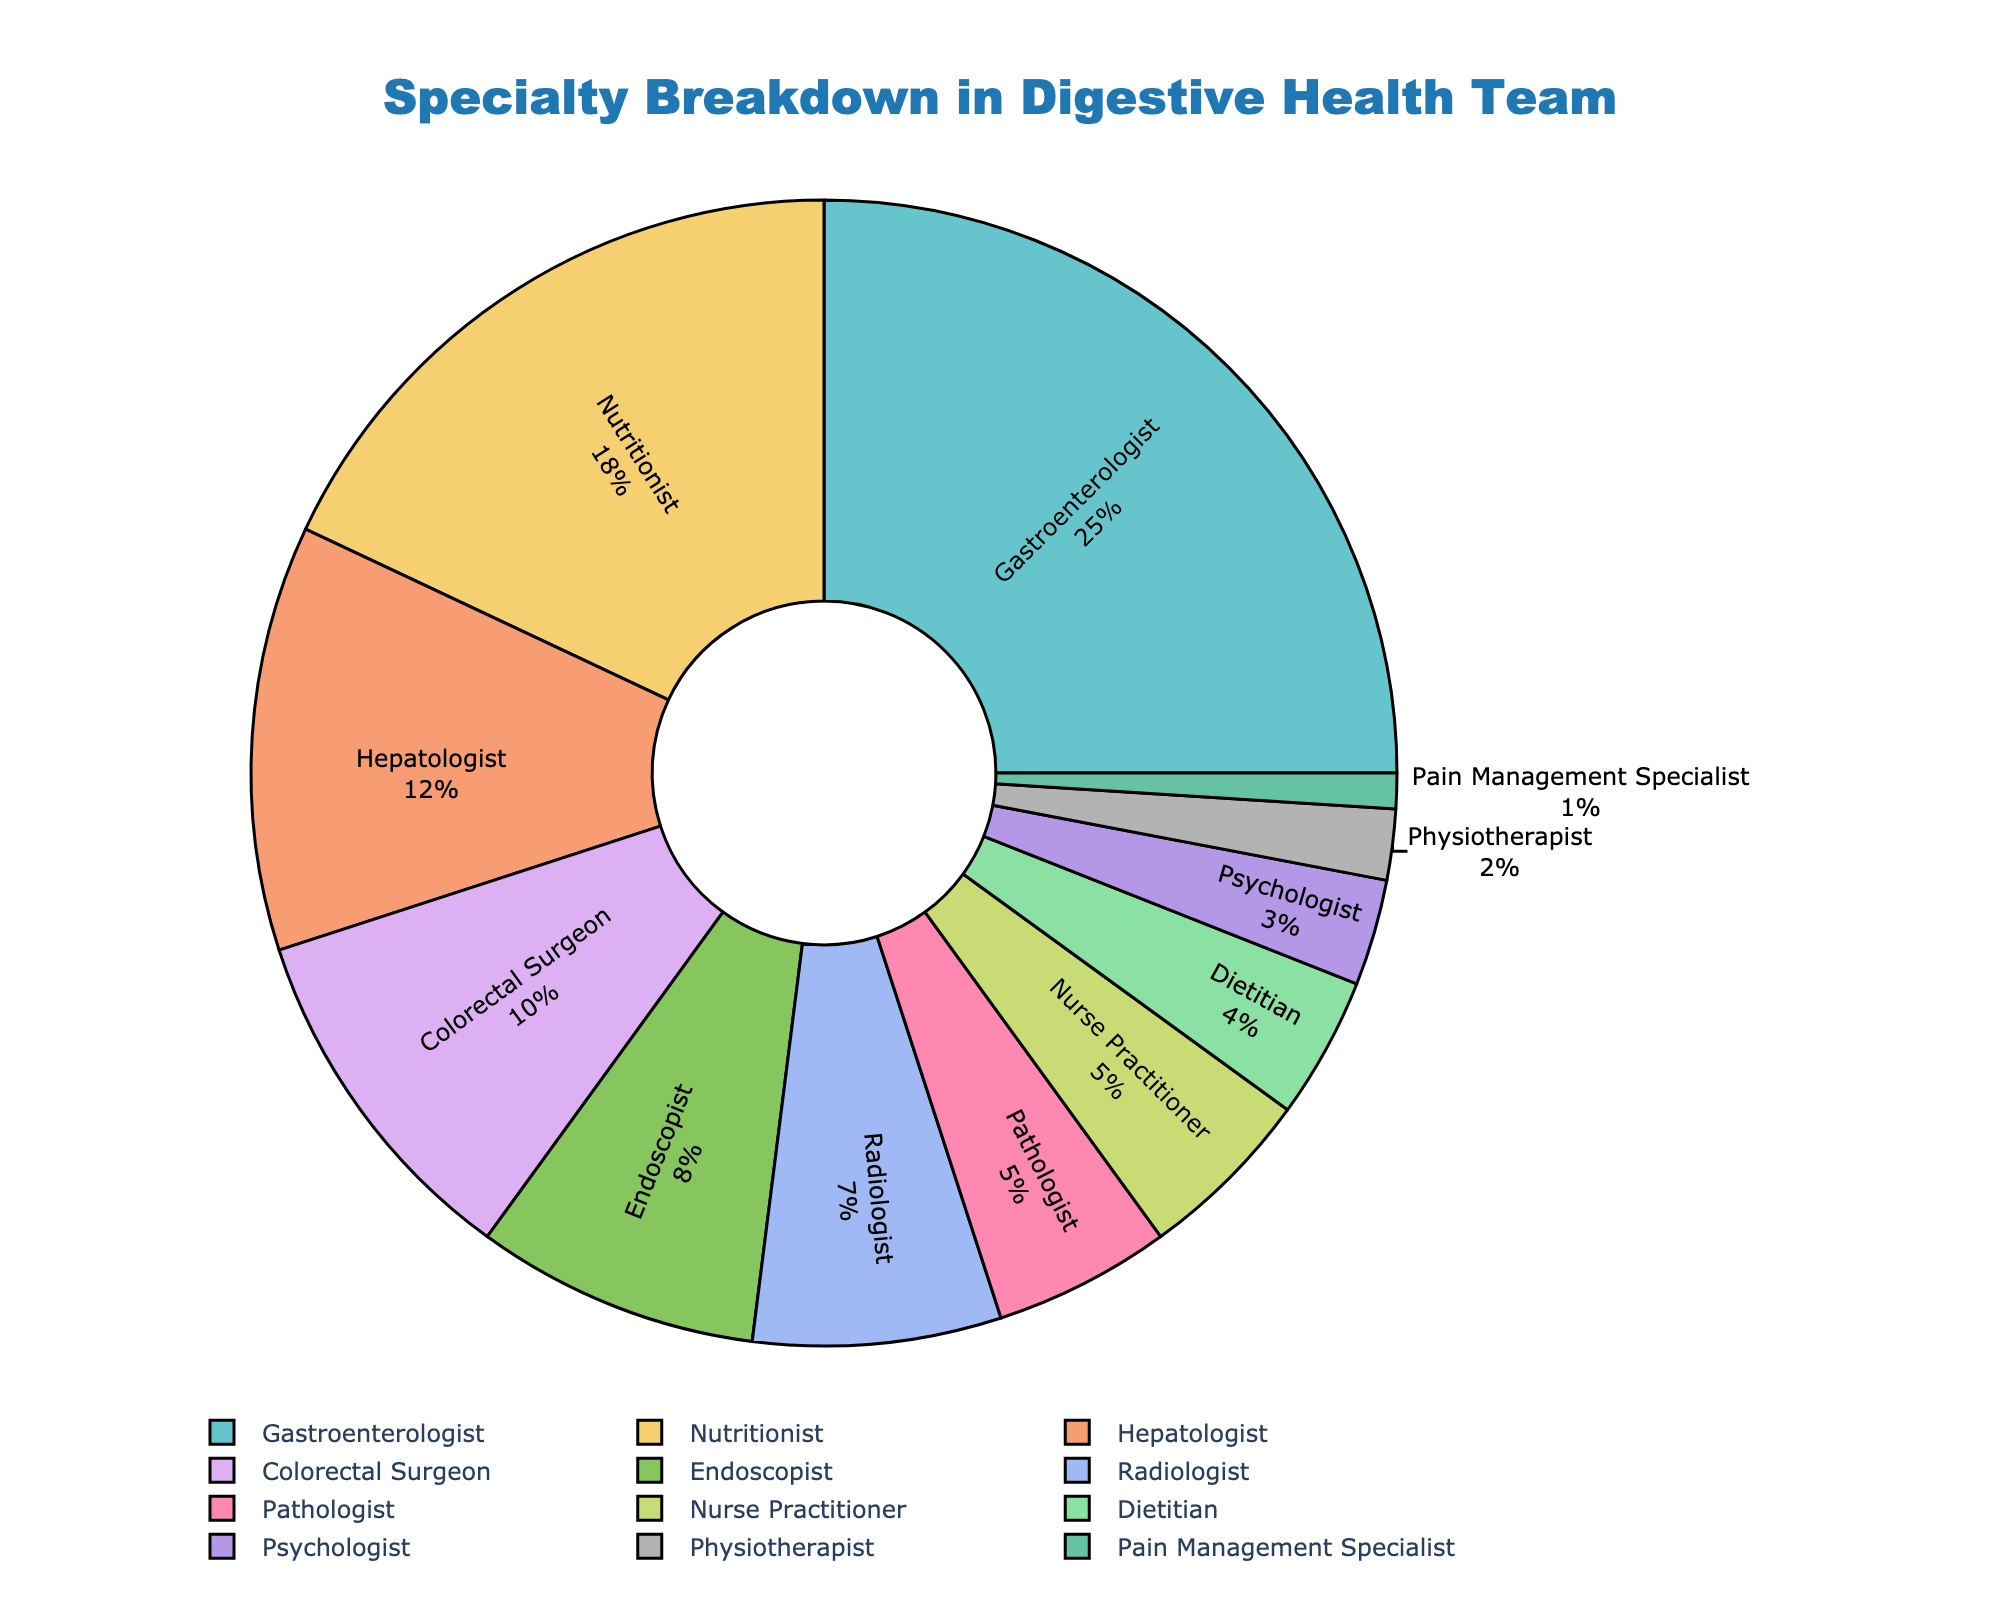What percentage of the team is made up of Gastroenterologists? Identify the section labeled "Gastroenterologist" on the pie chart. The chart indicates that Gastroenterologists make up 25% of the team.
Answer: 25% Which specialty contributes the least to the team? Locate the smallest segment in the pie chart. The segment labeled "Pain Management Specialist" represents the smallest percentage at 1%.
Answer: Pain Management Specialist What is the combined percentage of Endoscopists, Radiologists, and Pathologists? Identify the percentages of Endoscopists (8%), Radiologists (7%), and Pathologists (5%), and then sum these values: 8 + 7 + 5 = 20%.
Answer: 20% How does the percentage of Nurse Practitioners compare to that of Dietitians? Identify the sections labeled "Nurse Practitioner" and "Dietitian" to compare their percentages. Nurse Practitioners make up 5% while Dietitians account for 4%. Therefore, Nurse Practitioners have a 1% higher representation.
Answer: 1% higher Which specialties together make up nearly half of the team (close to 50%)? Identify combinations of the largest segments that sum to near 50%. Gastroenterologists (25%) and Nutritionists (18%) together make up 43%, whereas adding Hepatologists (12%) brings the total to 55%. Thus, Gastroenterologists and Nutritionists are closest to making up half of the team.
Answer: Gastroenterologists and Nutritionists What is the difference in percentage between Nutritionists and Physiotherapists? Identify the segments for Nutritionist (18%) and Physiotherapist (2%) and subtract the smaller percentage from the larger one: 18 - 2 = 16%.
Answer: 16% What specialty has a percentage closest to the average percentage of all specialties? Calculate the total percentage (100%) and divide by the number of specialties (12) to determine the average: 100 / 12 ≈ 8.33%. Endoscopists, at 8%, are closest to this average.
Answer: Endoscopist How does the percentage of Colorectal Surgeons compare to that of Hepatologists? Find the sections labeled Colorectal Surgeon (10%) and Hepatologist (12%) and compare. Colorectal Surgeons are 2% less than Hepatologists.
Answer: 2% less Which specialties' combined percentage equals the percentage of Gastroenterologists? Find combinations of segments that sum to 25%. Nutritionist (18%) and of the segments totaling to 7%, we find Radiologist (7%). Thus, Nutritionist and Radiologist together equal 25%, which matches the Gastroenterologist segment.
Answer: Nutritionist and Radiologist What is the visual angle of the segment for Pain Management Specialists relative to the entire pie? A full pie chart represents 360 degrees. The Pain Management Specialist segment is 1%, so the angle is 1% of 360 degrees: (1/100) * 360 = 3.6 degrees.
Answer: 3.6 degrees 